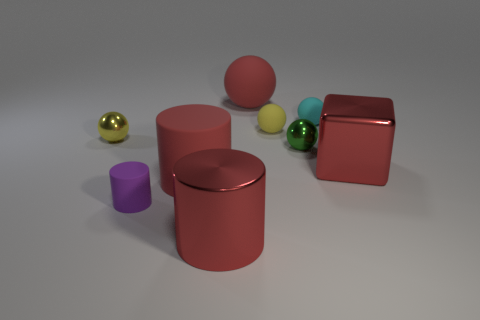What material is the tiny object in front of the large red metal thing on the right side of the matte thing behind the cyan rubber ball?
Your answer should be very brief. Rubber. Is the number of yellow metallic objects greater than the number of large red things?
Make the answer very short. No. Are there any other things of the same color as the big rubber cylinder?
Give a very brief answer. Yes. There is a red sphere that is the same material as the purple cylinder; what is its size?
Offer a very short reply. Large. What material is the red ball?
Make the answer very short. Rubber. What number of cylinders have the same size as the cube?
Your answer should be very brief. 2. What is the shape of the matte thing that is the same color as the big rubber sphere?
Ensure brevity in your answer.  Cylinder. Are there any big gray rubber things that have the same shape as the cyan rubber thing?
Your answer should be compact. No. There is a cylinder that is the same size as the yellow metallic object; what color is it?
Offer a terse response. Purple. What is the color of the thing that is behind the cyan rubber sphere that is in front of the red rubber sphere?
Give a very brief answer. Red. 